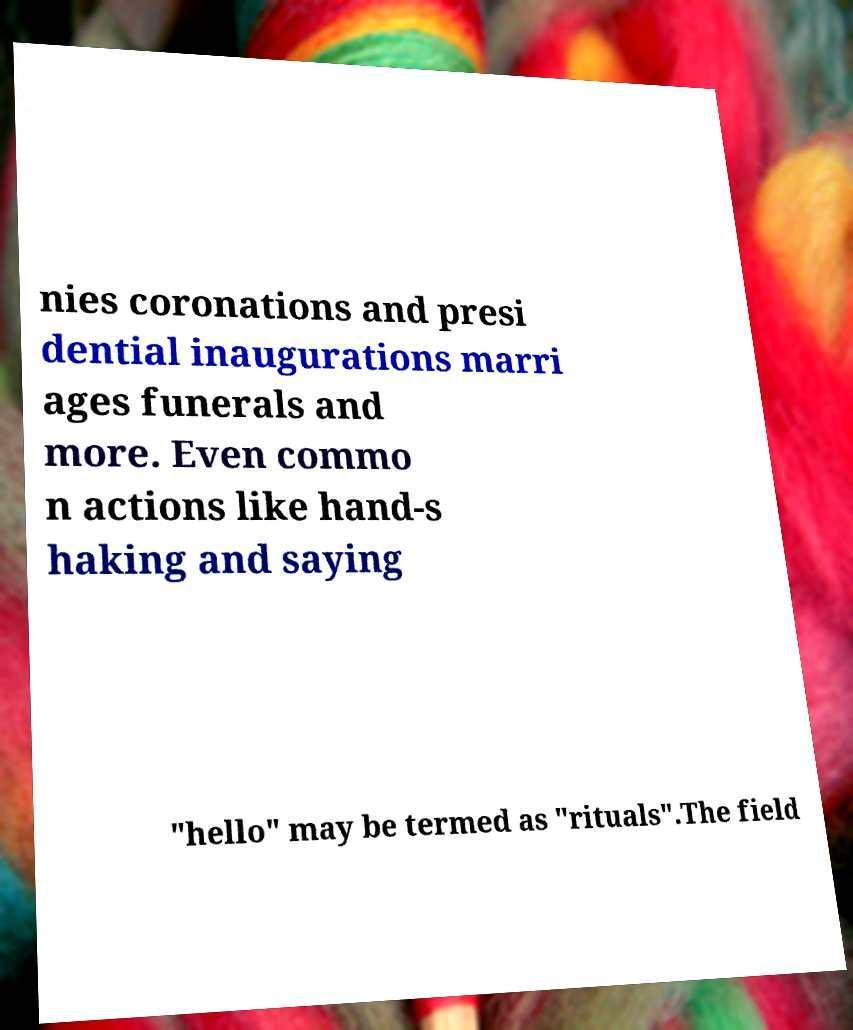I need the written content from this picture converted into text. Can you do that? nies coronations and presi dential inaugurations marri ages funerals and more. Even commo n actions like hand-s haking and saying "hello" may be termed as "rituals".The field 